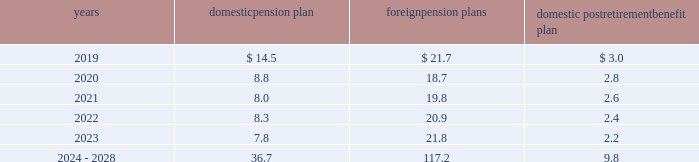Notes to consolidated financial statements 2013 ( continued ) ( amounts in millions , except per share amounts ) the estimated future benefit payments expected to be paid are presented below .
Domestic pension plan foreign pension plans domestic postretirement benefit plan .
The estimated future payments for our domestic postretirement benefit plan are net of any estimated u.s .
Federal subsidies expected to be received under the medicare prescription drug , improvement and modernization act of 2003 , which total no more than $ 0.3 in any individual year .
Savings plans we sponsor defined contribution plans ( the 201csavings plans 201d ) that cover substantially all domestic employees .
The savings plans permit participants to make contributions on a pre-tax and/or after-tax basis and allow participants to choose among various investment alternatives .
We match a portion of participant contributions based upon their years of service .
Amounts expensed for the savings plans for 2018 , 2017 and 2016 were $ 52.6 , $ 47.2 and $ 47.0 , respectively .
Expenses include a discretionary company contribution of $ 6.7 , $ 3.6 and $ 6.1 offset by participant forfeitures of $ 5.8 , $ 4.6 and $ 4.4 in 2018 , 2017 and 2016 , respectively .
In addition , we maintain defined contribution plans in various foreign countries and contributed $ 51.3 , $ 47.4 and $ 44.5 to these plans in 2018 , 2017 and 2016 , respectively .
Deferred compensation and benefit arrangements we have deferred compensation and benefit arrangements which ( i ) permit certain of our key officers and employees to defer a portion of their salary or incentive compensation or ( ii ) require us to contribute an amount to the participant 2019s account .
These arrangements may provide participants with the amounts deferred plus interest upon attaining certain conditions , such as completing a certain number of years of service , attaining a certain age or upon retirement or termination .
As of december 31 , 2018 and 2017 , the deferred compensation and deferred benefit liability balance was $ 196.2 and $ 213.2 , respectively .
Amounts expensed for deferred compensation and benefit arrangements in 2018 , 2017 and 2016 were $ 10.0 , $ 18.5 and $ 18.5 , respectively .
We have purchased life insurance policies on participants 2019 lives to assist in the funding of the related deferred compensation and deferred benefit liabilities .
As of december 31 , 2018 and 2017 , the cash surrender value of these policies was $ 177.3 and $ 177.4 , respectively .
Long-term disability plan we have a long-term disability plan which provides income replacement benefits to eligible participants who are unable to perform their job duties or any job related to his or her education , training or experience .
As all income replacement benefits are fully insured , no related obligation is required as of december 31 , 2018 and 2017 .
In addition to income replacement benefits , plan participants may remain covered for certain health and life insurance benefits up to normal retirement age , and accordingly , we have recorded an obligation of $ 5.9 and $ 8.4 as of december 31 , 2018 and 2017 , respectively. .
Which five year span , 2019-2023 or 2024-2028 , has a larger combined domestic pension plan? 
Computations: (((((14.5 + 8.8) + 8.0) + 8.3) + 7.8) - 36.7)
Answer: 10.7. 